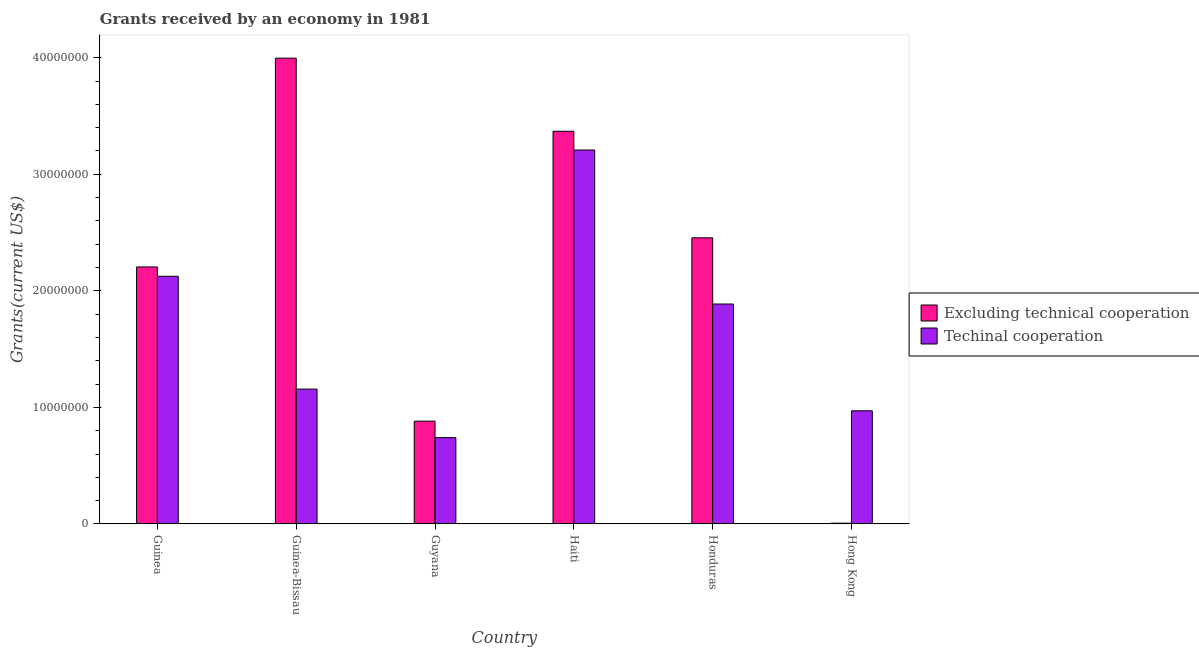How many different coloured bars are there?
Provide a short and direct response. 2. How many groups of bars are there?
Your answer should be compact. 6. Are the number of bars per tick equal to the number of legend labels?
Give a very brief answer. Yes. How many bars are there on the 3rd tick from the left?
Offer a terse response. 2. What is the label of the 2nd group of bars from the left?
Make the answer very short. Guinea-Bissau. In how many cases, is the number of bars for a given country not equal to the number of legend labels?
Offer a terse response. 0. What is the amount of grants received(including technical cooperation) in Guinea-Bissau?
Make the answer very short. 1.16e+07. Across all countries, what is the maximum amount of grants received(excluding technical cooperation)?
Make the answer very short. 4.00e+07. Across all countries, what is the minimum amount of grants received(including technical cooperation)?
Offer a terse response. 7.41e+06. In which country was the amount of grants received(including technical cooperation) maximum?
Offer a terse response. Haiti. In which country was the amount of grants received(excluding technical cooperation) minimum?
Make the answer very short. Hong Kong. What is the total amount of grants received(excluding technical cooperation) in the graph?
Your response must be concise. 1.29e+08. What is the difference between the amount of grants received(excluding technical cooperation) in Guyana and that in Hong Kong?
Your answer should be very brief. 8.75e+06. What is the difference between the amount of grants received(including technical cooperation) in Guyana and the amount of grants received(excluding technical cooperation) in Hong Kong?
Provide a short and direct response. 7.34e+06. What is the average amount of grants received(excluding technical cooperation) per country?
Make the answer very short. 2.15e+07. What is the difference between the amount of grants received(excluding technical cooperation) and amount of grants received(including technical cooperation) in Hong Kong?
Provide a succinct answer. -9.64e+06. What is the ratio of the amount of grants received(including technical cooperation) in Honduras to that in Hong Kong?
Your answer should be very brief. 1.94. Is the difference between the amount of grants received(excluding technical cooperation) in Guinea and Guyana greater than the difference between the amount of grants received(including technical cooperation) in Guinea and Guyana?
Provide a short and direct response. No. What is the difference between the highest and the second highest amount of grants received(including technical cooperation)?
Provide a short and direct response. 1.08e+07. What is the difference between the highest and the lowest amount of grants received(excluding technical cooperation)?
Provide a succinct answer. 3.99e+07. In how many countries, is the amount of grants received(including technical cooperation) greater than the average amount of grants received(including technical cooperation) taken over all countries?
Provide a succinct answer. 3. Is the sum of the amount of grants received(including technical cooperation) in Guinea and Honduras greater than the maximum amount of grants received(excluding technical cooperation) across all countries?
Keep it short and to the point. Yes. What does the 1st bar from the left in Guinea-Bissau represents?
Offer a terse response. Excluding technical cooperation. What does the 2nd bar from the right in Honduras represents?
Ensure brevity in your answer.  Excluding technical cooperation. How many bars are there?
Offer a very short reply. 12. Are all the bars in the graph horizontal?
Make the answer very short. No. How many countries are there in the graph?
Your answer should be very brief. 6. Does the graph contain any zero values?
Your answer should be very brief. No. Does the graph contain grids?
Your answer should be very brief. No. Where does the legend appear in the graph?
Offer a terse response. Center right. How many legend labels are there?
Give a very brief answer. 2. What is the title of the graph?
Ensure brevity in your answer.  Grants received by an economy in 1981. What is the label or title of the Y-axis?
Offer a terse response. Grants(current US$). What is the Grants(current US$) in Excluding technical cooperation in Guinea?
Ensure brevity in your answer.  2.20e+07. What is the Grants(current US$) of Techinal cooperation in Guinea?
Give a very brief answer. 2.12e+07. What is the Grants(current US$) in Excluding technical cooperation in Guinea-Bissau?
Provide a short and direct response. 4.00e+07. What is the Grants(current US$) in Techinal cooperation in Guinea-Bissau?
Your answer should be compact. 1.16e+07. What is the Grants(current US$) of Excluding technical cooperation in Guyana?
Keep it short and to the point. 8.82e+06. What is the Grants(current US$) in Techinal cooperation in Guyana?
Your response must be concise. 7.41e+06. What is the Grants(current US$) of Excluding technical cooperation in Haiti?
Your response must be concise. 3.37e+07. What is the Grants(current US$) in Techinal cooperation in Haiti?
Keep it short and to the point. 3.21e+07. What is the Grants(current US$) of Excluding technical cooperation in Honduras?
Offer a terse response. 2.46e+07. What is the Grants(current US$) of Techinal cooperation in Honduras?
Ensure brevity in your answer.  1.89e+07. What is the Grants(current US$) of Excluding technical cooperation in Hong Kong?
Make the answer very short. 7.00e+04. What is the Grants(current US$) in Techinal cooperation in Hong Kong?
Offer a very short reply. 9.71e+06. Across all countries, what is the maximum Grants(current US$) in Excluding technical cooperation?
Offer a very short reply. 4.00e+07. Across all countries, what is the maximum Grants(current US$) in Techinal cooperation?
Your answer should be very brief. 3.21e+07. Across all countries, what is the minimum Grants(current US$) of Excluding technical cooperation?
Provide a succinct answer. 7.00e+04. Across all countries, what is the minimum Grants(current US$) of Techinal cooperation?
Your answer should be compact. 7.41e+06. What is the total Grants(current US$) of Excluding technical cooperation in the graph?
Offer a very short reply. 1.29e+08. What is the total Grants(current US$) in Techinal cooperation in the graph?
Ensure brevity in your answer.  1.01e+08. What is the difference between the Grants(current US$) of Excluding technical cooperation in Guinea and that in Guinea-Bissau?
Your answer should be very brief. -1.79e+07. What is the difference between the Grants(current US$) in Techinal cooperation in Guinea and that in Guinea-Bissau?
Offer a terse response. 9.68e+06. What is the difference between the Grants(current US$) in Excluding technical cooperation in Guinea and that in Guyana?
Make the answer very short. 1.32e+07. What is the difference between the Grants(current US$) of Techinal cooperation in Guinea and that in Guyana?
Offer a terse response. 1.38e+07. What is the difference between the Grants(current US$) in Excluding technical cooperation in Guinea and that in Haiti?
Offer a very short reply. -1.16e+07. What is the difference between the Grants(current US$) in Techinal cooperation in Guinea and that in Haiti?
Offer a very short reply. -1.08e+07. What is the difference between the Grants(current US$) of Excluding technical cooperation in Guinea and that in Honduras?
Offer a terse response. -2.50e+06. What is the difference between the Grants(current US$) in Techinal cooperation in Guinea and that in Honduras?
Provide a succinct answer. 2.38e+06. What is the difference between the Grants(current US$) in Excluding technical cooperation in Guinea and that in Hong Kong?
Offer a very short reply. 2.20e+07. What is the difference between the Grants(current US$) of Techinal cooperation in Guinea and that in Hong Kong?
Make the answer very short. 1.15e+07. What is the difference between the Grants(current US$) in Excluding technical cooperation in Guinea-Bissau and that in Guyana?
Your answer should be compact. 3.11e+07. What is the difference between the Grants(current US$) of Techinal cooperation in Guinea-Bissau and that in Guyana?
Keep it short and to the point. 4.16e+06. What is the difference between the Grants(current US$) of Excluding technical cooperation in Guinea-Bissau and that in Haiti?
Your answer should be compact. 6.27e+06. What is the difference between the Grants(current US$) of Techinal cooperation in Guinea-Bissau and that in Haiti?
Give a very brief answer. -2.05e+07. What is the difference between the Grants(current US$) in Excluding technical cooperation in Guinea-Bissau and that in Honduras?
Provide a short and direct response. 1.54e+07. What is the difference between the Grants(current US$) in Techinal cooperation in Guinea-Bissau and that in Honduras?
Give a very brief answer. -7.30e+06. What is the difference between the Grants(current US$) of Excluding technical cooperation in Guinea-Bissau and that in Hong Kong?
Your answer should be very brief. 3.99e+07. What is the difference between the Grants(current US$) of Techinal cooperation in Guinea-Bissau and that in Hong Kong?
Provide a succinct answer. 1.86e+06. What is the difference between the Grants(current US$) of Excluding technical cooperation in Guyana and that in Haiti?
Your answer should be compact. -2.49e+07. What is the difference between the Grants(current US$) in Techinal cooperation in Guyana and that in Haiti?
Offer a terse response. -2.47e+07. What is the difference between the Grants(current US$) in Excluding technical cooperation in Guyana and that in Honduras?
Provide a succinct answer. -1.57e+07. What is the difference between the Grants(current US$) in Techinal cooperation in Guyana and that in Honduras?
Ensure brevity in your answer.  -1.15e+07. What is the difference between the Grants(current US$) of Excluding technical cooperation in Guyana and that in Hong Kong?
Provide a short and direct response. 8.75e+06. What is the difference between the Grants(current US$) in Techinal cooperation in Guyana and that in Hong Kong?
Your response must be concise. -2.30e+06. What is the difference between the Grants(current US$) in Excluding technical cooperation in Haiti and that in Honduras?
Give a very brief answer. 9.14e+06. What is the difference between the Grants(current US$) in Techinal cooperation in Haiti and that in Honduras?
Your response must be concise. 1.32e+07. What is the difference between the Grants(current US$) of Excluding technical cooperation in Haiti and that in Hong Kong?
Offer a terse response. 3.36e+07. What is the difference between the Grants(current US$) of Techinal cooperation in Haiti and that in Hong Kong?
Provide a short and direct response. 2.24e+07. What is the difference between the Grants(current US$) in Excluding technical cooperation in Honduras and that in Hong Kong?
Offer a terse response. 2.45e+07. What is the difference between the Grants(current US$) of Techinal cooperation in Honduras and that in Hong Kong?
Your answer should be compact. 9.16e+06. What is the difference between the Grants(current US$) in Excluding technical cooperation in Guinea and the Grants(current US$) in Techinal cooperation in Guinea-Bissau?
Offer a very short reply. 1.05e+07. What is the difference between the Grants(current US$) of Excluding technical cooperation in Guinea and the Grants(current US$) of Techinal cooperation in Guyana?
Offer a very short reply. 1.46e+07. What is the difference between the Grants(current US$) in Excluding technical cooperation in Guinea and the Grants(current US$) in Techinal cooperation in Haiti?
Provide a short and direct response. -1.00e+07. What is the difference between the Grants(current US$) of Excluding technical cooperation in Guinea and the Grants(current US$) of Techinal cooperation in Honduras?
Offer a very short reply. 3.18e+06. What is the difference between the Grants(current US$) of Excluding technical cooperation in Guinea and the Grants(current US$) of Techinal cooperation in Hong Kong?
Provide a short and direct response. 1.23e+07. What is the difference between the Grants(current US$) of Excluding technical cooperation in Guinea-Bissau and the Grants(current US$) of Techinal cooperation in Guyana?
Your answer should be compact. 3.26e+07. What is the difference between the Grants(current US$) of Excluding technical cooperation in Guinea-Bissau and the Grants(current US$) of Techinal cooperation in Haiti?
Ensure brevity in your answer.  7.88e+06. What is the difference between the Grants(current US$) of Excluding technical cooperation in Guinea-Bissau and the Grants(current US$) of Techinal cooperation in Honduras?
Keep it short and to the point. 2.11e+07. What is the difference between the Grants(current US$) in Excluding technical cooperation in Guinea-Bissau and the Grants(current US$) in Techinal cooperation in Hong Kong?
Offer a terse response. 3.02e+07. What is the difference between the Grants(current US$) of Excluding technical cooperation in Guyana and the Grants(current US$) of Techinal cooperation in Haiti?
Your answer should be compact. -2.33e+07. What is the difference between the Grants(current US$) in Excluding technical cooperation in Guyana and the Grants(current US$) in Techinal cooperation in Honduras?
Your response must be concise. -1.00e+07. What is the difference between the Grants(current US$) of Excluding technical cooperation in Guyana and the Grants(current US$) of Techinal cooperation in Hong Kong?
Give a very brief answer. -8.90e+05. What is the difference between the Grants(current US$) in Excluding technical cooperation in Haiti and the Grants(current US$) in Techinal cooperation in Honduras?
Give a very brief answer. 1.48e+07. What is the difference between the Grants(current US$) of Excluding technical cooperation in Haiti and the Grants(current US$) of Techinal cooperation in Hong Kong?
Your answer should be very brief. 2.40e+07. What is the difference between the Grants(current US$) of Excluding technical cooperation in Honduras and the Grants(current US$) of Techinal cooperation in Hong Kong?
Provide a short and direct response. 1.48e+07. What is the average Grants(current US$) in Excluding technical cooperation per country?
Ensure brevity in your answer.  2.15e+07. What is the average Grants(current US$) of Techinal cooperation per country?
Ensure brevity in your answer.  1.68e+07. What is the difference between the Grants(current US$) of Excluding technical cooperation and Grants(current US$) of Techinal cooperation in Guinea-Bissau?
Provide a short and direct response. 2.84e+07. What is the difference between the Grants(current US$) of Excluding technical cooperation and Grants(current US$) of Techinal cooperation in Guyana?
Your response must be concise. 1.41e+06. What is the difference between the Grants(current US$) of Excluding technical cooperation and Grants(current US$) of Techinal cooperation in Haiti?
Give a very brief answer. 1.61e+06. What is the difference between the Grants(current US$) in Excluding technical cooperation and Grants(current US$) in Techinal cooperation in Honduras?
Your answer should be very brief. 5.68e+06. What is the difference between the Grants(current US$) of Excluding technical cooperation and Grants(current US$) of Techinal cooperation in Hong Kong?
Keep it short and to the point. -9.64e+06. What is the ratio of the Grants(current US$) of Excluding technical cooperation in Guinea to that in Guinea-Bissau?
Make the answer very short. 0.55. What is the ratio of the Grants(current US$) in Techinal cooperation in Guinea to that in Guinea-Bissau?
Ensure brevity in your answer.  1.84. What is the ratio of the Grants(current US$) in Excluding technical cooperation in Guinea to that in Guyana?
Give a very brief answer. 2.5. What is the ratio of the Grants(current US$) of Techinal cooperation in Guinea to that in Guyana?
Your answer should be compact. 2.87. What is the ratio of the Grants(current US$) in Excluding technical cooperation in Guinea to that in Haiti?
Your answer should be very brief. 0.65. What is the ratio of the Grants(current US$) in Techinal cooperation in Guinea to that in Haiti?
Your answer should be very brief. 0.66. What is the ratio of the Grants(current US$) of Excluding technical cooperation in Guinea to that in Honduras?
Provide a succinct answer. 0.9. What is the ratio of the Grants(current US$) of Techinal cooperation in Guinea to that in Honduras?
Your response must be concise. 1.13. What is the ratio of the Grants(current US$) of Excluding technical cooperation in Guinea to that in Hong Kong?
Give a very brief answer. 315. What is the ratio of the Grants(current US$) of Techinal cooperation in Guinea to that in Hong Kong?
Provide a short and direct response. 2.19. What is the ratio of the Grants(current US$) in Excluding technical cooperation in Guinea-Bissau to that in Guyana?
Make the answer very short. 4.53. What is the ratio of the Grants(current US$) of Techinal cooperation in Guinea-Bissau to that in Guyana?
Your answer should be very brief. 1.56. What is the ratio of the Grants(current US$) in Excluding technical cooperation in Guinea-Bissau to that in Haiti?
Your answer should be very brief. 1.19. What is the ratio of the Grants(current US$) in Techinal cooperation in Guinea-Bissau to that in Haiti?
Ensure brevity in your answer.  0.36. What is the ratio of the Grants(current US$) of Excluding technical cooperation in Guinea-Bissau to that in Honduras?
Your response must be concise. 1.63. What is the ratio of the Grants(current US$) of Techinal cooperation in Guinea-Bissau to that in Honduras?
Offer a terse response. 0.61. What is the ratio of the Grants(current US$) of Excluding technical cooperation in Guinea-Bissau to that in Hong Kong?
Provide a short and direct response. 570.86. What is the ratio of the Grants(current US$) in Techinal cooperation in Guinea-Bissau to that in Hong Kong?
Provide a short and direct response. 1.19. What is the ratio of the Grants(current US$) in Excluding technical cooperation in Guyana to that in Haiti?
Ensure brevity in your answer.  0.26. What is the ratio of the Grants(current US$) of Techinal cooperation in Guyana to that in Haiti?
Make the answer very short. 0.23. What is the ratio of the Grants(current US$) in Excluding technical cooperation in Guyana to that in Honduras?
Your answer should be very brief. 0.36. What is the ratio of the Grants(current US$) of Techinal cooperation in Guyana to that in Honduras?
Your answer should be compact. 0.39. What is the ratio of the Grants(current US$) of Excluding technical cooperation in Guyana to that in Hong Kong?
Give a very brief answer. 126. What is the ratio of the Grants(current US$) of Techinal cooperation in Guyana to that in Hong Kong?
Your answer should be very brief. 0.76. What is the ratio of the Grants(current US$) in Excluding technical cooperation in Haiti to that in Honduras?
Give a very brief answer. 1.37. What is the ratio of the Grants(current US$) of Techinal cooperation in Haiti to that in Honduras?
Your answer should be compact. 1.7. What is the ratio of the Grants(current US$) in Excluding technical cooperation in Haiti to that in Hong Kong?
Provide a short and direct response. 481.29. What is the ratio of the Grants(current US$) in Techinal cooperation in Haiti to that in Hong Kong?
Make the answer very short. 3.3. What is the ratio of the Grants(current US$) of Excluding technical cooperation in Honduras to that in Hong Kong?
Your response must be concise. 350.71. What is the ratio of the Grants(current US$) in Techinal cooperation in Honduras to that in Hong Kong?
Offer a very short reply. 1.94. What is the difference between the highest and the second highest Grants(current US$) in Excluding technical cooperation?
Your answer should be compact. 6.27e+06. What is the difference between the highest and the second highest Grants(current US$) in Techinal cooperation?
Your answer should be compact. 1.08e+07. What is the difference between the highest and the lowest Grants(current US$) of Excluding technical cooperation?
Your answer should be very brief. 3.99e+07. What is the difference between the highest and the lowest Grants(current US$) in Techinal cooperation?
Provide a succinct answer. 2.47e+07. 